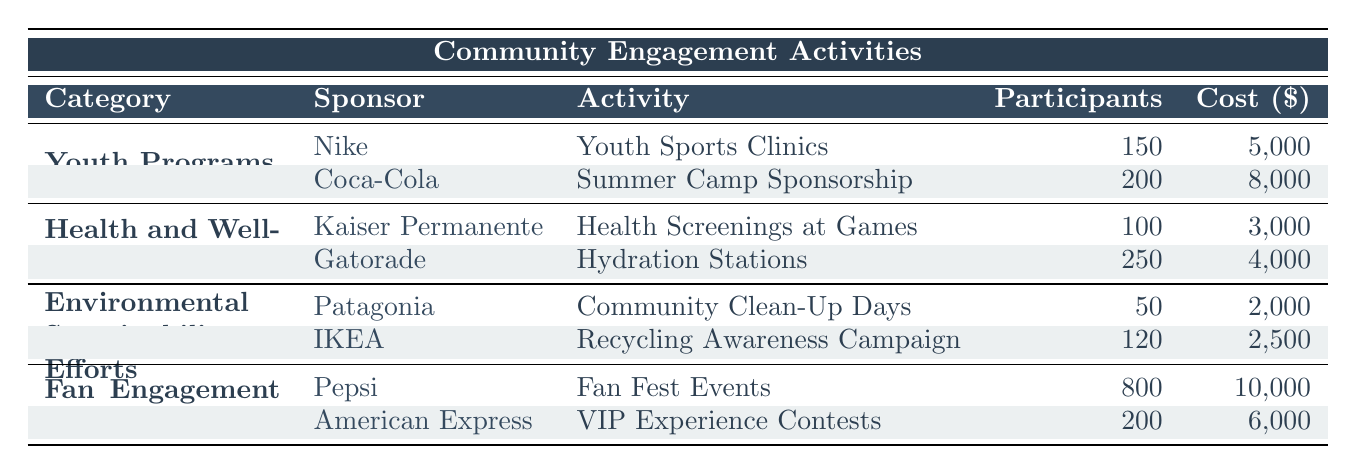What are the total participants involved in Youth Programs? There are two sponsor involvements listed under Youth Programs: Nike with 150 participants and Coca-Cola with 200 participants. Adding these gives a total of 150 + 200 = 350 participants in Youth Programs.
Answer: 350 Which sponsor was involved in the Health and Wellness Initiatives that had the highest number of participants? In the Health and Wellness Initiatives, Kaiser Permanente had 100 participants, while Gatorade had 250 participants. Gatorade had the highest number of participants among the two sponsors.
Answer: Gatorade Is it true that Patagonia sponsored an activity with more participants than IKEA? Patagonia had 50 participants for the Community Clean-Up Days, while IKEA had 120 participants for the Recycling Awareness Campaign. Since 50 is not greater than 120, the statement is false.
Answer: No What is the total cost of the Environmental Sustainability Efforts? Patagonia's Community Clean-Up Days cost $2,000, and IKEA's Recycling Awareness Campaign cost $2,500. To find the total, we add these costs together: 2,000 + 2,500 = 4,500.
Answer: 4,500 Which category had the most participants overall, and how many were there? We need to sum the participants for each category. Youth Programs has 350, Health and Wellness Initiatives has 350, Environmental Sustainability Efforts has 170, and Fan Engagement Activities has 1,000. The highest number is from Fan Engagement Activities, which had 1,000 participants.
Answer: Fan Engagement Activities, 1,000 